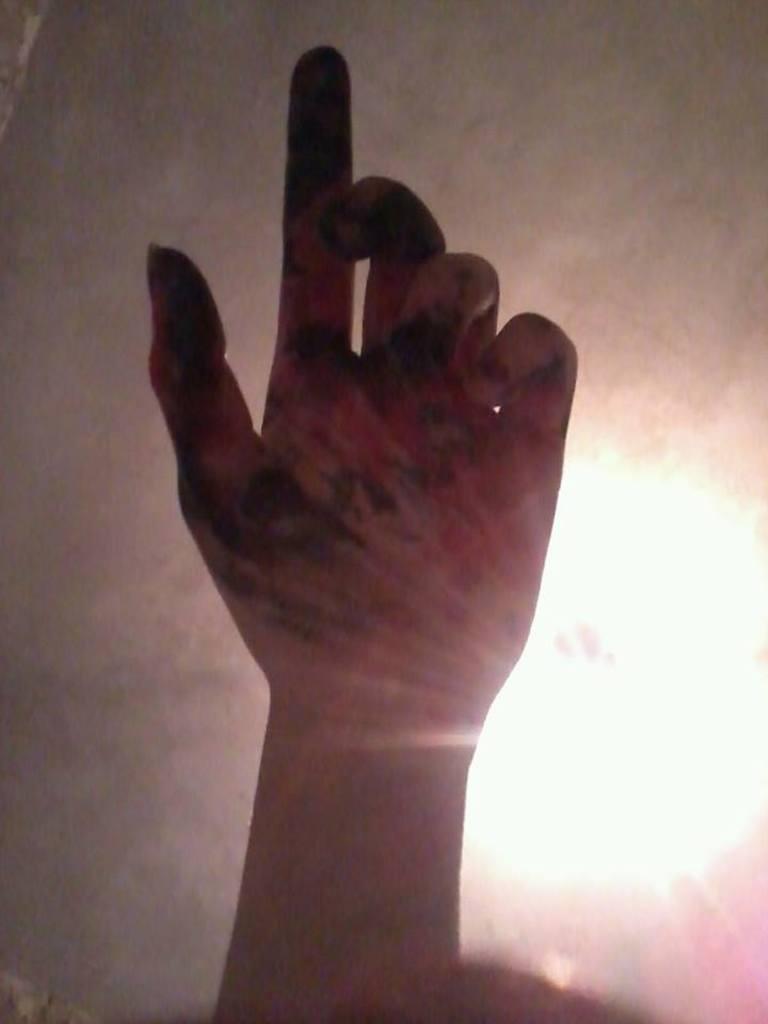In one or two sentences, can you explain what this image depicts? In the center of the image we can see one human hand. In the background, we can see the light and a few other objects. 